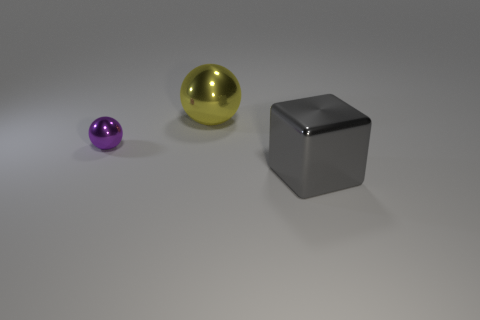What number of things are large things that are on the left side of the big gray metal object or spheres behind the tiny thing?
Ensure brevity in your answer.  1. What number of other objects are there of the same size as the gray thing?
Your answer should be compact. 1. What is the shape of the big shiny thing that is to the right of the big metal object that is on the left side of the big block?
Provide a succinct answer. Cube. The big cube is what color?
Offer a terse response. Gray. Are there any big cyan metallic cylinders?
Offer a terse response. No. Are there any small things in front of the big gray shiny block?
Your response must be concise. No. What number of other objects are there of the same shape as the purple metallic thing?
Offer a very short reply. 1. What number of objects are in front of the object that is on the right side of the metallic ball right of the purple metal thing?
Your answer should be very brief. 0. What number of other small things are the same shape as the small metallic thing?
Your answer should be very brief. 0. There is a large metallic object to the right of the big object to the left of the object in front of the small purple metallic object; what is its shape?
Offer a terse response. Cube. 